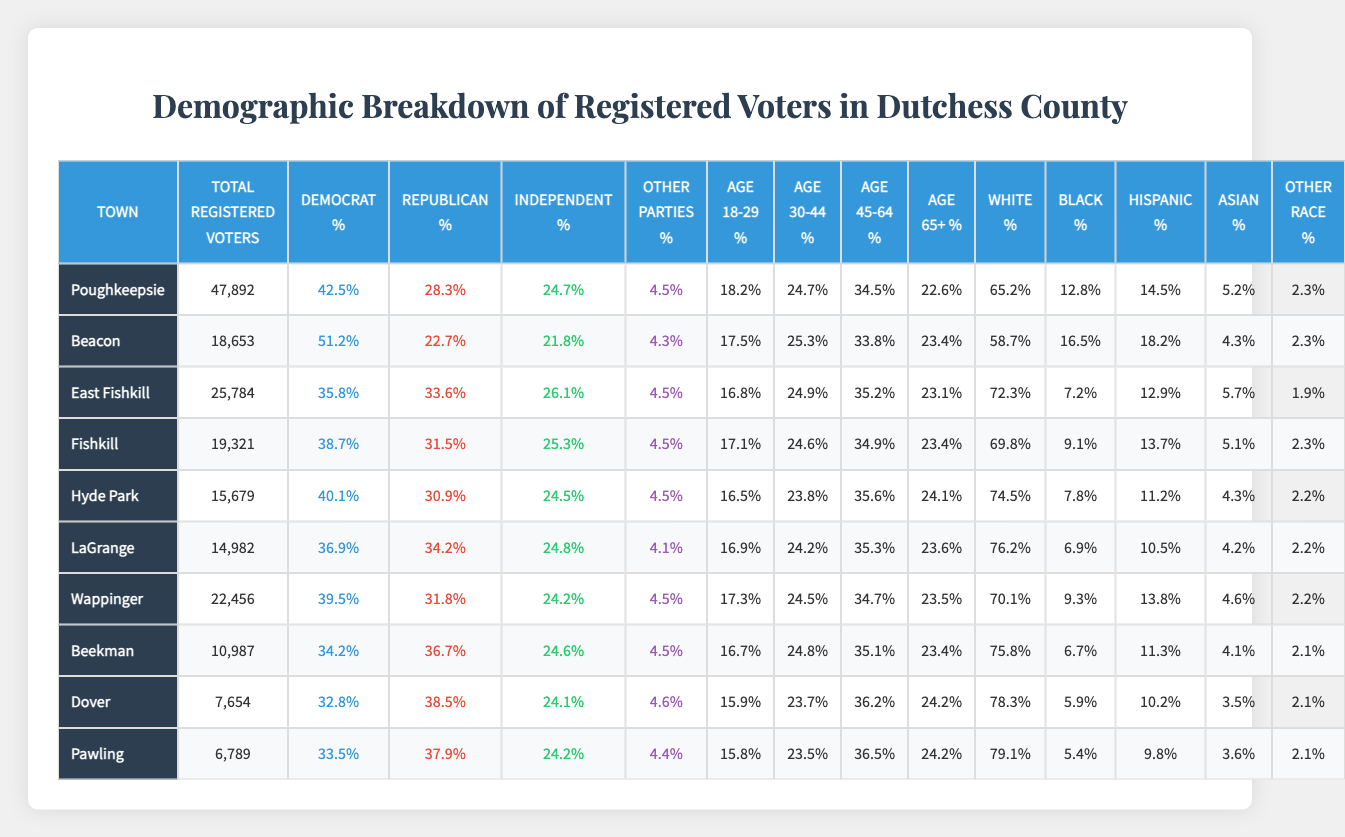What town has the highest percentage of registered Democrats? Looking at the "Democrat %" column, Beacon has the highest percentage at 51.2%.
Answer: Beacon What is the total number of registered voters in Poughkeepsie? The "Total Registered Voters" for Poughkeepsie is listed as 47,892.
Answer: 47,892 Which town has the lowest percentage of Hispanic registered voters? The "Hispanic %" for Pawling is 9.8%, which is the lowest in the table.
Answer: Pawling What is the percentage of independent voters in Fishkill? The "Independent %" for Fishkill is 25.3%.
Answer: 25.3% Which town shows a higher percentage of Republican voters, Wappinger or LaGrange? Wappinger has 31.8% Republican voters while LaGrange has 34.2%, indicating LaGrange has a higher percentage.
Answer: LaGrange What is the average percentage of voters aged 18-29 across all towns? The percentages for age 18-29 are 18.2, 17.5, 16.8, 17.1, 16.5, 16.9, 17.3, 16.7, 15.9, and 15.8. Summing these gives 173.7, and dividing by 10 towns gives an average of 17.37%.
Answer: 17.37% Is the percentage of Black voters in Poughkeepsie higher than in Beacon? Poughkeepsie has 12.8% Black voters while Beacon has 16.5%. Since 12.8% is less than 16.5%, the statement is false.
Answer: No What is the difference in the percentage of white voters between Dover and Fishkill? Dover has 78.3% white voters and Fishkill has 69.8%. The difference is calculated as 78.3 - 69.8 = 8.5%.
Answer: 8.5% Which town has the lowest number of total registered voters? The lowest number of total registered voters is in Beekman with 10,987 voters.
Answer: Beekman What is the percentage of registered voters aged 45-64 in Poughkeepsie? The "Age 45-64 %" for Poughkeepsie is 34.5%.
Answer: 34.5% How many towns have more than 40% of registered Democrats? Poughkeepsie, Beacon, and Hyde Park are the towns with more than 40% registered Democrats, totaling 3 towns.
Answer: 3 